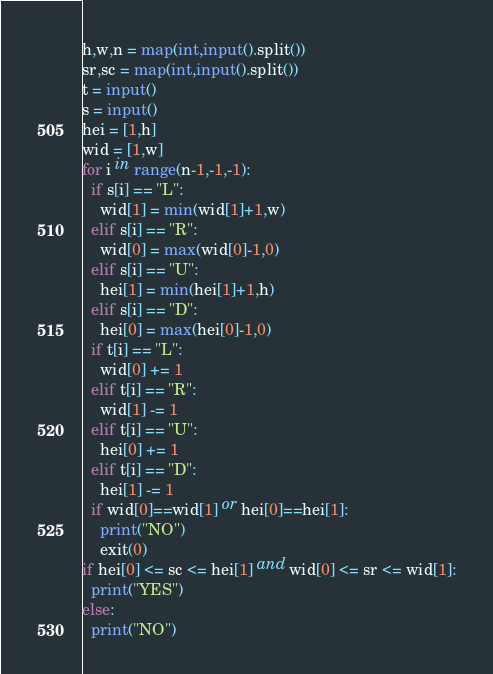<code> <loc_0><loc_0><loc_500><loc_500><_Python_>h,w,n = map(int,input().split())
sr,sc = map(int,input().split())
t = input()
s = input()
hei = [1,h]
wid = [1,w]
for i in range(n-1,-1,-1):
  if s[i] == "L":
    wid[1] = min(wid[1]+1,w)
  elif s[i] == "R":
    wid[0] = max(wid[0]-1,0)
  elif s[i] == "U":
    hei[1] = min(hei[1]+1,h)
  elif s[i] == "D":
    hei[0] = max(hei[0]-1,0)
  if t[i] == "L":
    wid[0] += 1
  elif t[i] == "R":
    wid[1] -= 1
  elif t[i] == "U":
    hei[0] += 1
  elif t[i] == "D":
    hei[1] -= 1
  if wid[0]==wid[1] or hei[0]==hei[1]:
    print("NO")
    exit(0)
if hei[0] <= sc <= hei[1] and wid[0] <= sr <= wid[1]:
  print("YES")
else:
  print("NO")</code> 